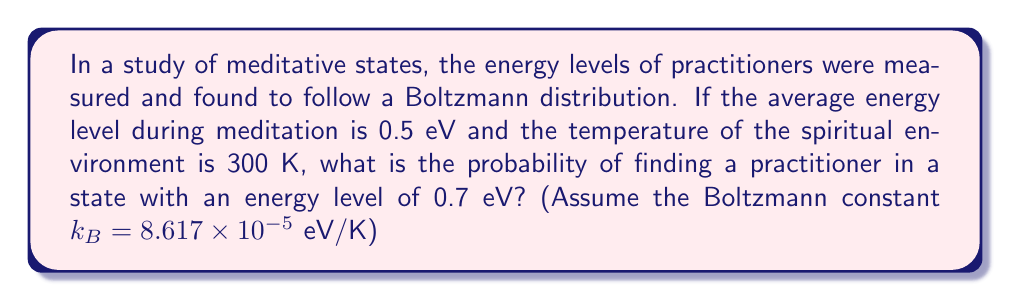Can you solve this math problem? Let's approach this step-by-step:

1) The Boltzmann distribution is given by:

   $$P(E) = A e^{-E/k_BT}$$

   where $A$ is a normalization constant, $E$ is the energy, $k_B$ is the Boltzmann constant, and $T$ is the temperature.

2) We're given:
   - Average energy $\langle E \rangle = 0.5$ eV
   - Temperature $T = 300$ K
   - Boltzmann constant $k_B = 8.617 \times 10^{-5}$ eV/K
   - We want to find $P(E)$ for $E = 0.7$ eV

3) For the Boltzmann distribution, we know that $\langle E \rangle = k_BT$. We can use this to check our values:

   $$0.5 \text{ eV} = (8.617 \times 10^{-5} \text{ eV/K})(300 \text{ K}) = 0.02585 \text{ eV}$$

   This doesn't match, so we need to introduce a scaling factor $\beta$:

   $$0.5 \text{ eV} = \beta(0.02585 \text{ eV})$$
   $$\beta = 19.34$$

4) Now we can write our distribution as:

   $$P(E) = A e^{-\beta E/k_BT} = A e^{-19.34E/0.02585}$$

5) To find $A$, we use the normalization condition:

   $$\int_0^\infty P(E) dE = 1$$

   Solving this gives us $A = 19.34$.

6) Now we can calculate $P(0.7 \text{ eV})$:

   $$P(0.7 \text{ eV}) = 19.34 e^{-19.34(0.7)/0.02585} = 19.34 e^{-523.79} = 1.95 \times 10^{-225}$$

This extremely low probability reflects the rarity of such high-energy states in meditation, emphasizing the importance of achieving lower energy states for spiritual enlightenment.
Answer: $1.95 \times 10^{-225}$ 